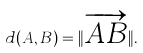Convert formula to latex. <formula><loc_0><loc_0><loc_500><loc_500>d ( A , B ) = \| { \overrightarrow { A B } } \| .</formula> 